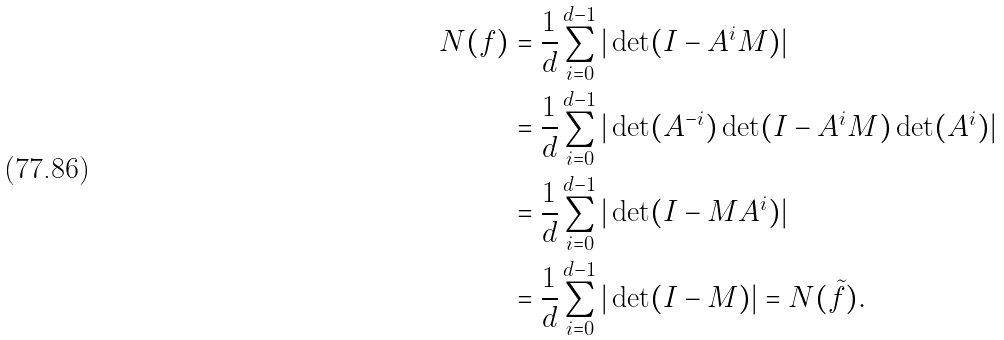Convert formula to latex. <formula><loc_0><loc_0><loc_500><loc_500>N ( f ) & = \frac { 1 } { d } \sum _ { i = 0 } ^ { d - 1 } | \det ( I - A ^ { i } M ) | \\ & = \frac { 1 } { d } \sum _ { i = 0 } ^ { d - 1 } | \det ( A ^ { - i } ) \det ( I - A ^ { i } M ) \det ( A ^ { i } ) | \\ & = \frac { 1 } { d } \sum _ { i = 0 } ^ { d - 1 } | \det ( I - M A ^ { i } ) | \\ & = \frac { 1 } { d } \sum _ { i = 0 } ^ { d - 1 } | \det ( I - M ) | = N ( \tilde { f } ) .</formula> 